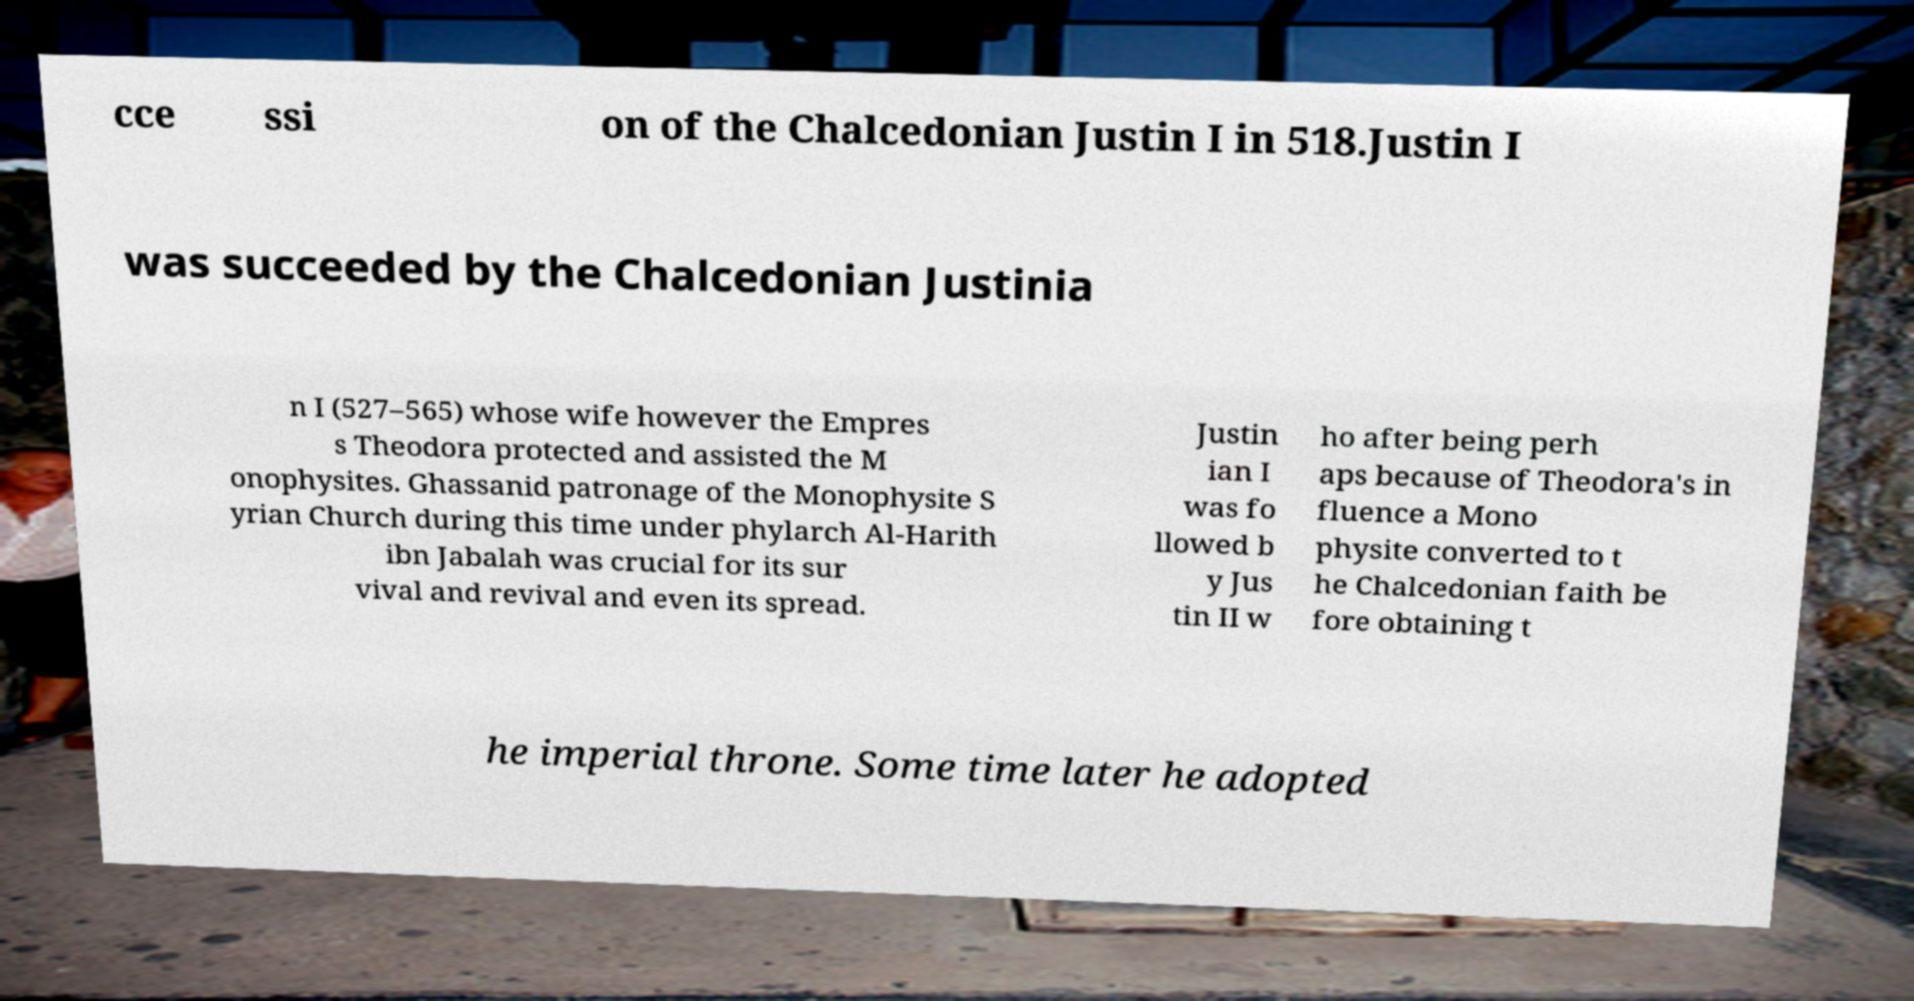Please identify and transcribe the text found in this image. cce ssi on of the Chalcedonian Justin I in 518.Justin I was succeeded by the Chalcedonian Justinia n I (527–565) whose wife however the Empres s Theodora protected and assisted the M onophysites. Ghassanid patronage of the Monophysite S yrian Church during this time under phylarch Al-Harith ibn Jabalah was crucial for its sur vival and revival and even its spread. Justin ian I was fo llowed b y Jus tin II w ho after being perh aps because of Theodora's in fluence a Mono physite converted to t he Chalcedonian faith be fore obtaining t he imperial throne. Some time later he adopted 